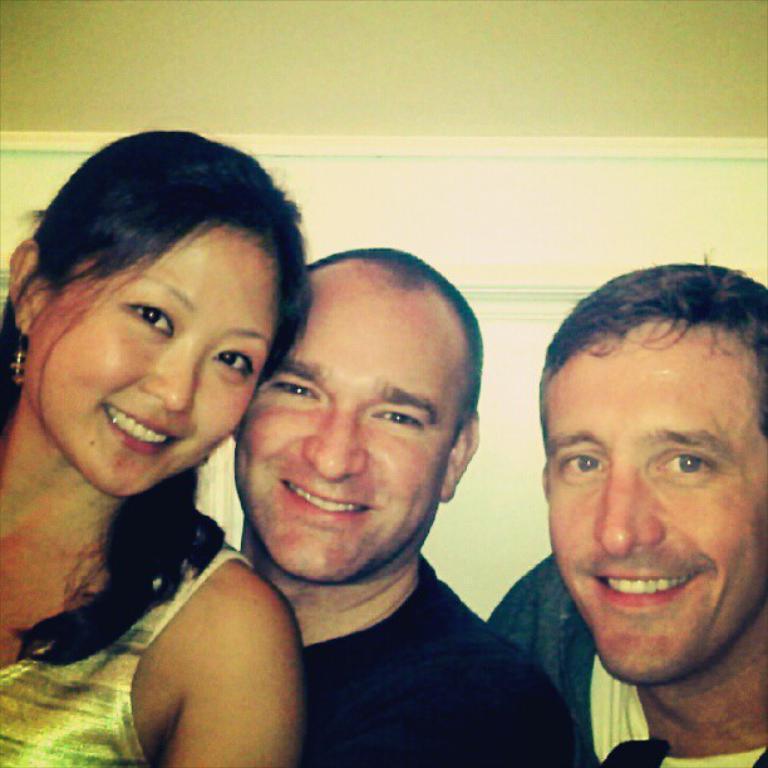How would you summarize this image in a sentence or two? On the left side, there is a woman smiling. Beside her, there is a person in a black color T-shirt, smiling. On the right side, there is another person smiling. In the background, there is a wall. 